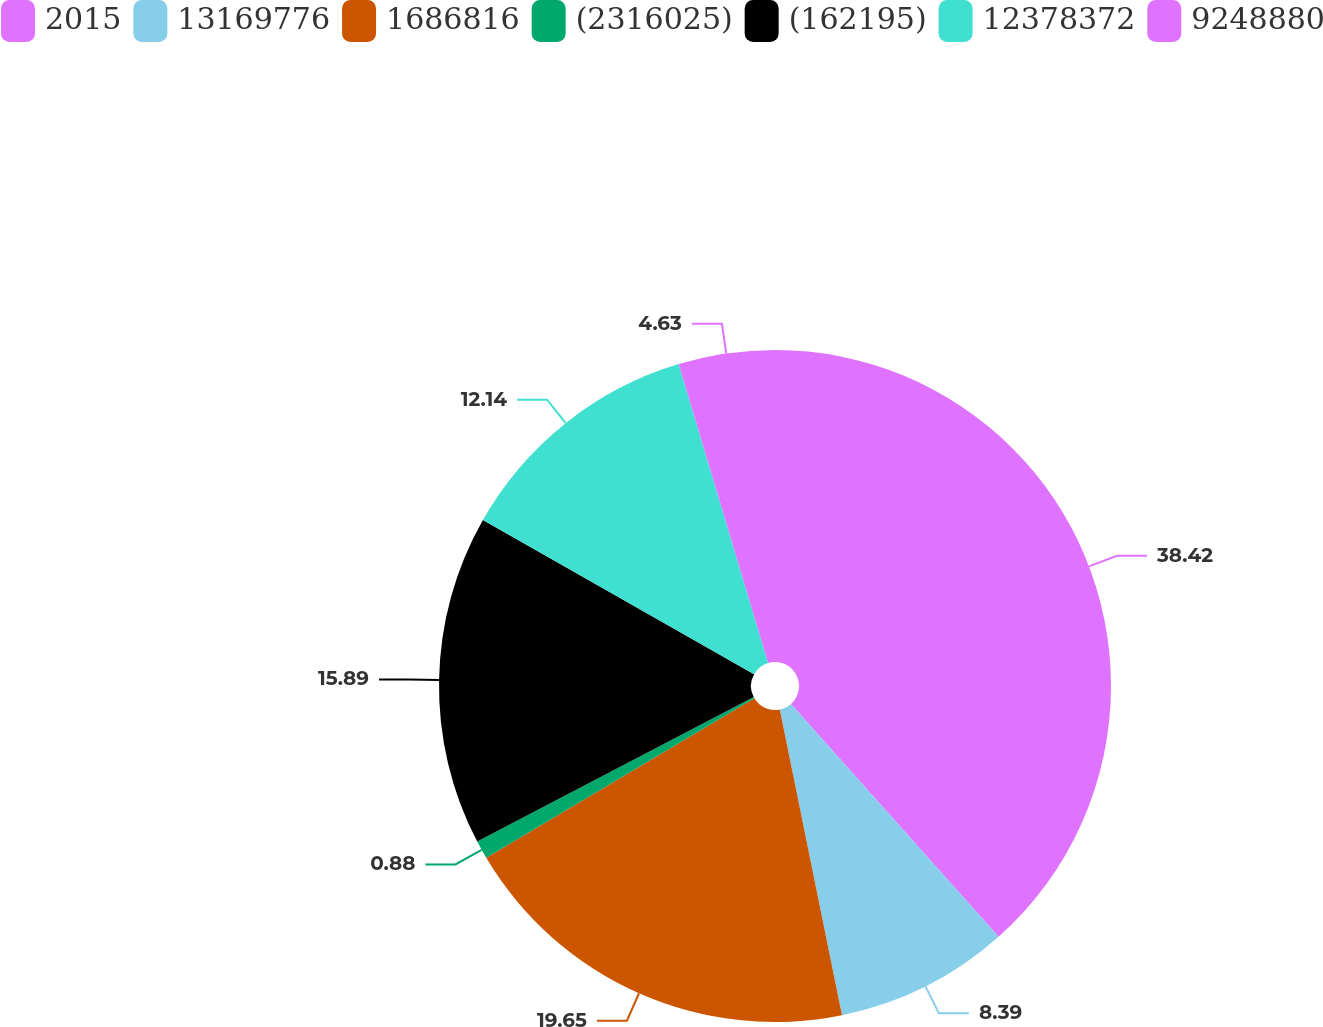<chart> <loc_0><loc_0><loc_500><loc_500><pie_chart><fcel>2015<fcel>13169776<fcel>1686816<fcel>(2316025)<fcel>(162195)<fcel>12378372<fcel>9248880<nl><fcel>38.41%<fcel>8.39%<fcel>19.65%<fcel>0.88%<fcel>15.89%<fcel>12.14%<fcel>4.63%<nl></chart> 